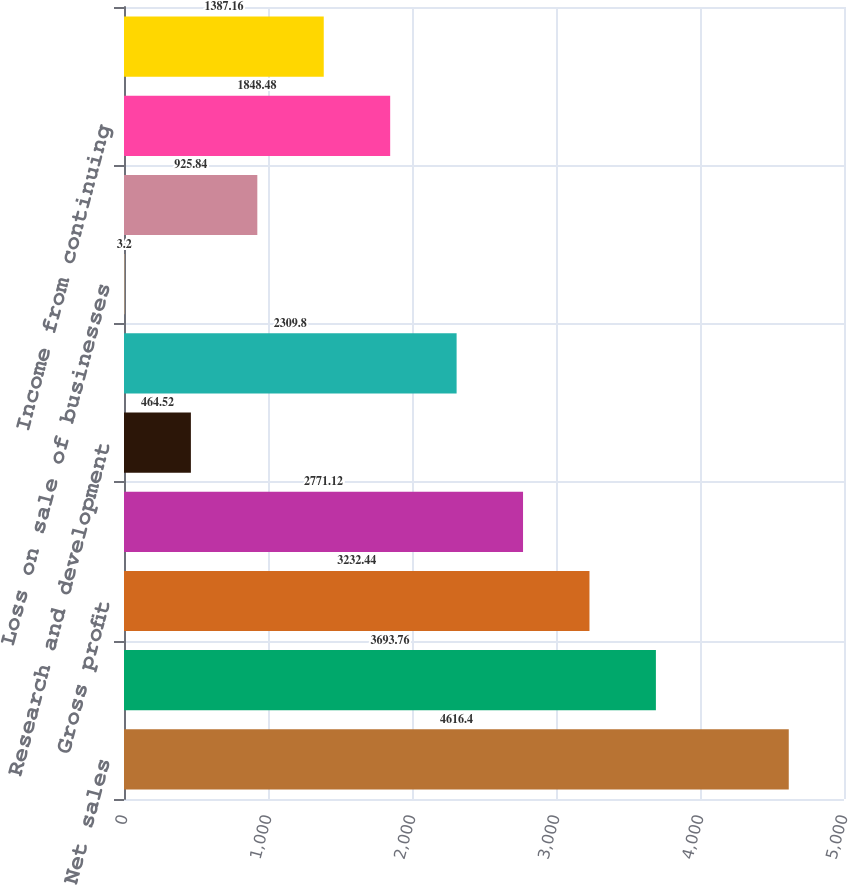Convert chart. <chart><loc_0><loc_0><loc_500><loc_500><bar_chart><fcel>Net sales<fcel>Cost of goods sold<fcel>Gross profit<fcel>Selling general and<fcel>Research and development<fcel>Operating income<fcel>Loss on sale of businesses<fcel>Net interest expense<fcel>Income from continuing<fcel>Provision for income taxes<nl><fcel>4616.4<fcel>3693.76<fcel>3232.44<fcel>2771.12<fcel>464.52<fcel>2309.8<fcel>3.2<fcel>925.84<fcel>1848.48<fcel>1387.16<nl></chart> 